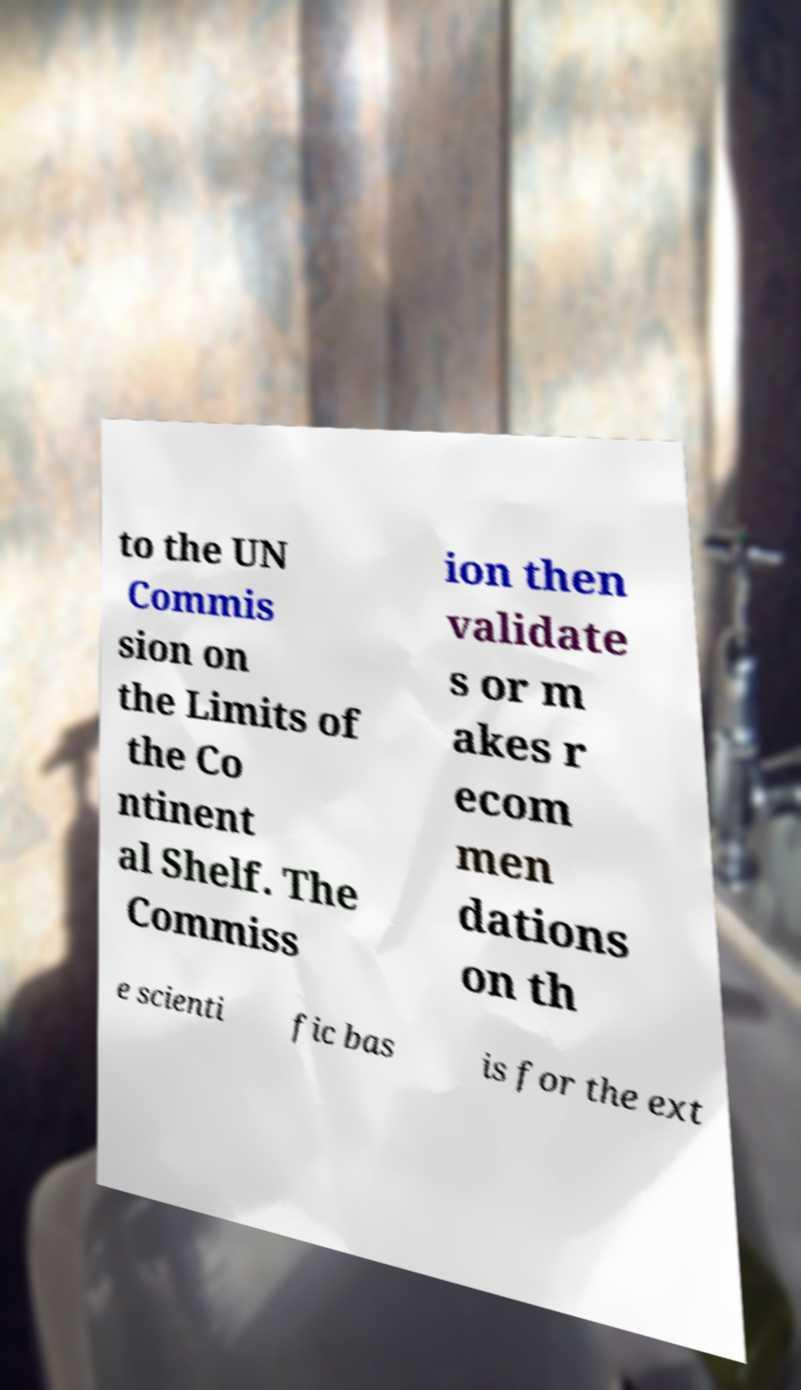What messages or text are displayed in this image? I need them in a readable, typed format. to the UN Commis sion on the Limits of the Co ntinent al Shelf. The Commiss ion then validate s or m akes r ecom men dations on th e scienti fic bas is for the ext 